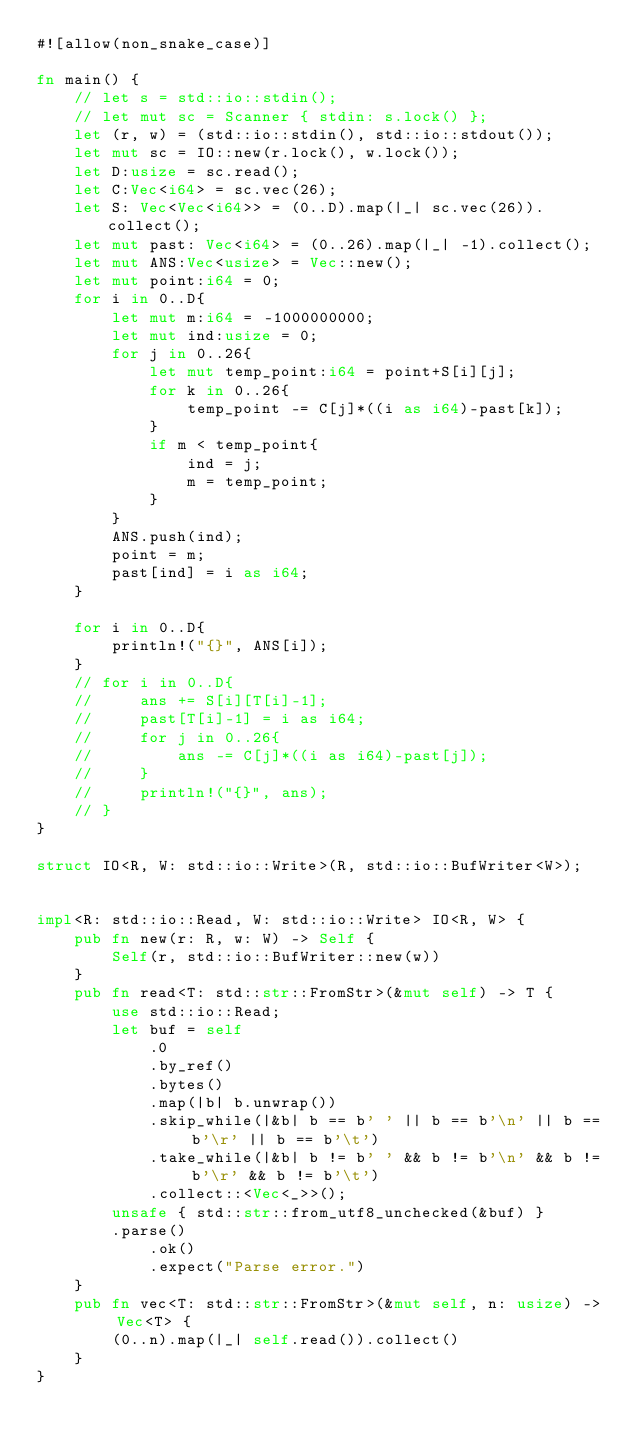<code> <loc_0><loc_0><loc_500><loc_500><_Rust_>#![allow(non_snake_case)]

fn main() {
    // let s = std::io::stdin();
    // let mut sc = Scanner { stdin: s.lock() };
    let (r, w) = (std::io::stdin(), std::io::stdout());
    let mut sc = IO::new(r.lock(), w.lock());
    let D:usize = sc.read();
    let C:Vec<i64> = sc.vec(26);
    let S: Vec<Vec<i64>> = (0..D).map(|_| sc.vec(26)).collect();
    let mut past: Vec<i64> = (0..26).map(|_| -1).collect();
    let mut ANS:Vec<usize> = Vec::new();
    let mut point:i64 = 0;
    for i in 0..D{
        let mut m:i64 = -1000000000;
        let mut ind:usize = 0;
        for j in 0..26{
            let mut temp_point:i64 = point+S[i][j];
            for k in 0..26{
                temp_point -= C[j]*((i as i64)-past[k]);
            }
            if m < temp_point{
                ind = j;
                m = temp_point;
            }
        }
        ANS.push(ind);
        point = m;
        past[ind] = i as i64;
    }

    for i in 0..D{
        println!("{}", ANS[i]);
    }
    // for i in 0..D{
    //     ans += S[i][T[i]-1];
    //     past[T[i]-1] = i as i64;
    //     for j in 0..26{
    //         ans -= C[j]*((i as i64)-past[j]);
    //     }
    //     println!("{}", ans);
    // }
}

struct IO<R, W: std::io::Write>(R, std::io::BufWriter<W>);


impl<R: std::io::Read, W: std::io::Write> IO<R, W> {
    pub fn new(r: R, w: W) -> Self {
        Self(r, std::io::BufWriter::new(w))
    }
    pub fn read<T: std::str::FromStr>(&mut self) -> T {
        use std::io::Read;
        let buf = self
            .0
            .by_ref()
            .bytes()
            .map(|b| b.unwrap())
            .skip_while(|&b| b == b' ' || b == b'\n' || b == b'\r' || b == b'\t')
            .take_while(|&b| b != b' ' && b != b'\n' && b != b'\r' && b != b'\t')
            .collect::<Vec<_>>();
        unsafe { std::str::from_utf8_unchecked(&buf) }
        .parse()
            .ok()
            .expect("Parse error.")
    }
    pub fn vec<T: std::str::FromStr>(&mut self, n: usize) -> Vec<T> {
        (0..n).map(|_| self.read()).collect()
    }
}



</code> 